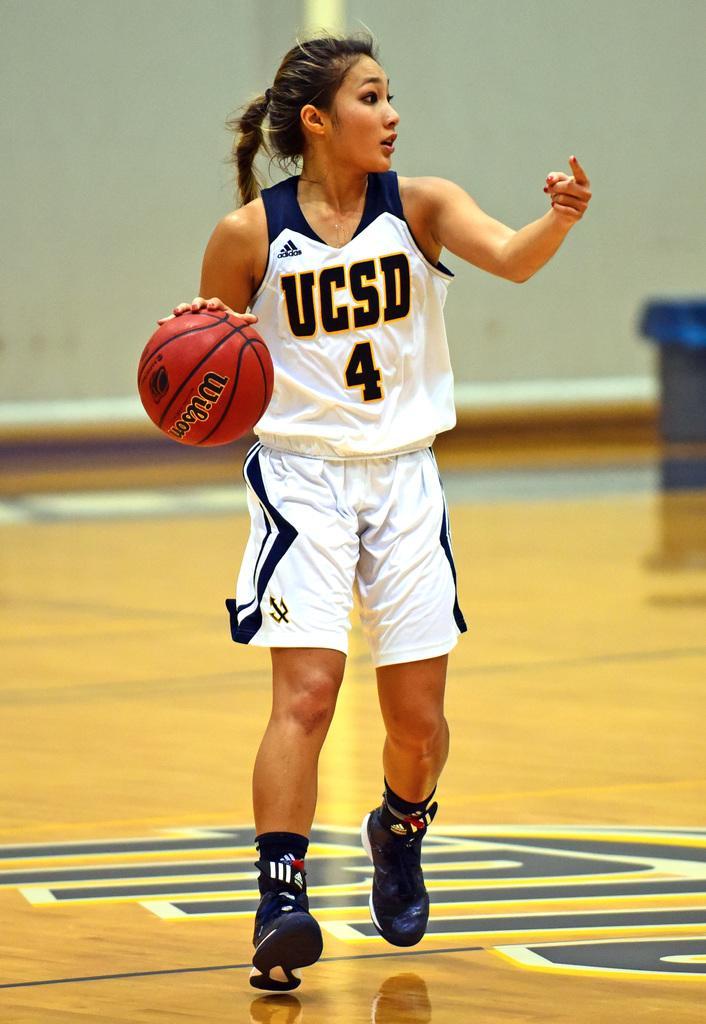Can you describe this image briefly? Here we can see a woman standing on the floor and holding a ball in her hands, and at back here is the wall. 